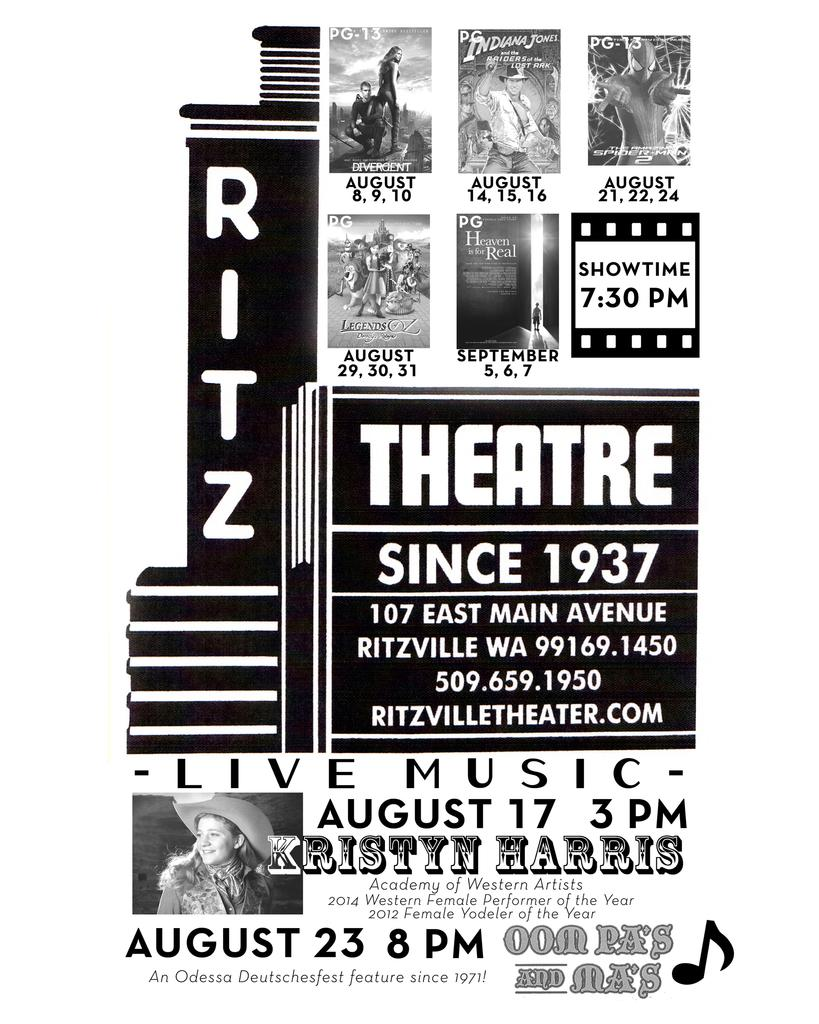<image>
Describe the image concisely. August and early September showtimes are displayed for the Ritz theatre. 